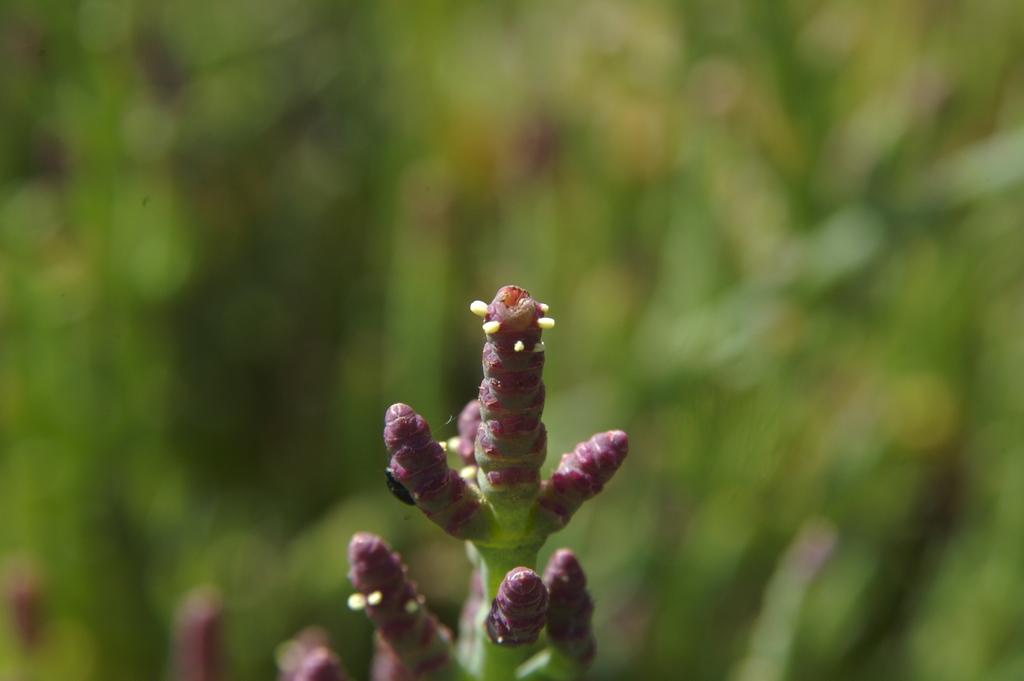What type of plant is visible in the image? The image contains the branches of a plant. What credit score does the girl in the image have? There is no girl or mention of a credit score in the image, as it only features the branches of a plant. 